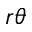<formula> <loc_0><loc_0><loc_500><loc_500>r \theta</formula> 